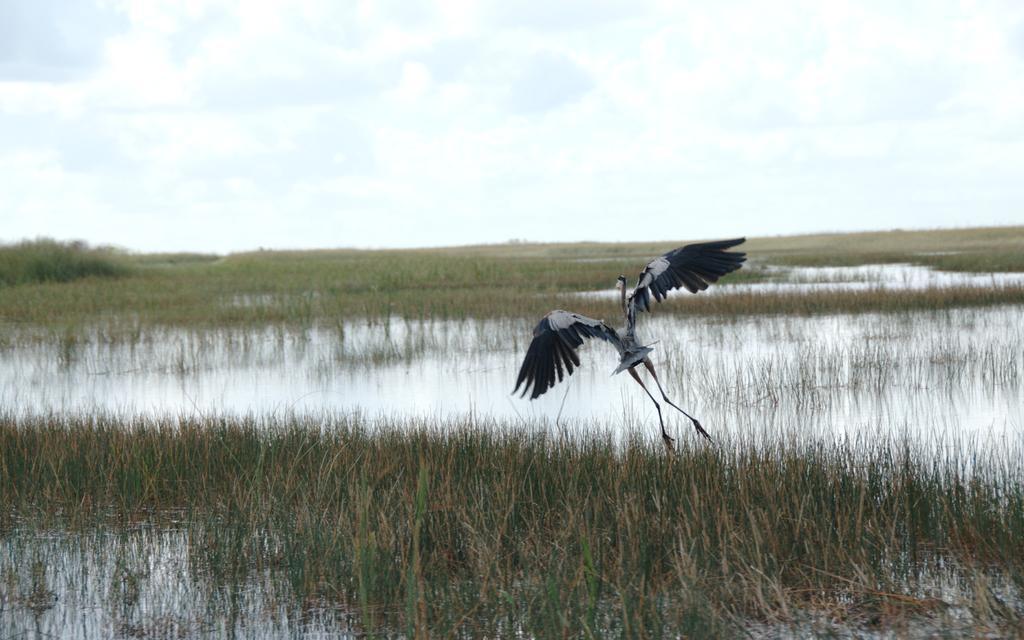In one or two sentences, can you explain what this image depicts? In this picture we can see the grass, water and a bird flying in the air. In the background we can see the sky with clouds. 